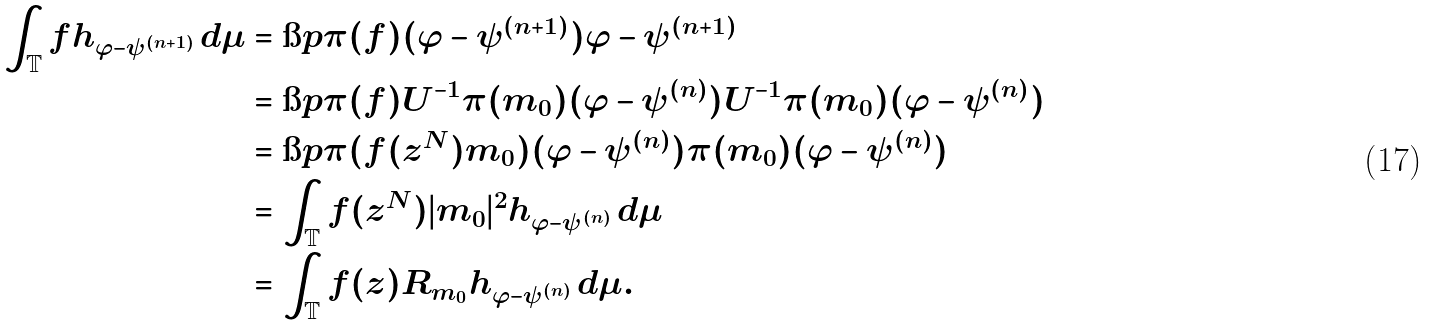Convert formula to latex. <formula><loc_0><loc_0><loc_500><loc_500>\int _ { \mathbb { T } } f h _ { \varphi - \psi ^ { ( n + 1 ) } } \, d \mu & = \i p { \pi ( f ) ( \varphi - \psi ^ { ( n + 1 ) } ) } { \varphi - \psi ^ { ( n + 1 ) } } \\ & = \i p { \pi ( f ) U ^ { - 1 } \pi ( m _ { 0 } ) ( \varphi - \psi ^ { ( n ) } ) } { U ^ { - 1 } \pi ( m _ { 0 } ) ( \varphi - \psi ^ { ( n ) } ) } \\ & = \i p { \pi ( f ( z ^ { N } ) m _ { 0 } ) ( \varphi - \psi ^ { ( n ) } ) } { \pi ( m _ { 0 } ) ( \varphi - \psi ^ { ( n ) } ) } \\ & = \int _ { \mathbb { T } } f ( z ^ { N } ) | m _ { 0 } | ^ { 2 } h _ { \varphi - \psi ^ { ( n ) } } \, d \mu \\ & = \int _ { \mathbb { T } } f ( z ) R _ { m _ { 0 } } h _ { \varphi - \psi ^ { ( n ) } } \, d \mu .</formula> 